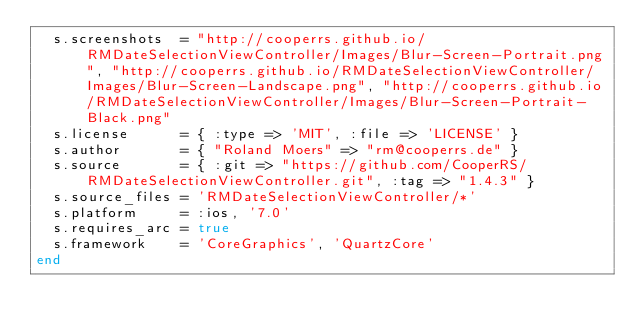<code> <loc_0><loc_0><loc_500><loc_500><_Ruby_>  s.screenshots  = "http://cooperrs.github.io/RMDateSelectionViewController/Images/Blur-Screen-Portrait.png", "http://cooperrs.github.io/RMDateSelectionViewController/Images/Blur-Screen-Landscape.png", "http://cooperrs.github.io/RMDateSelectionViewController/Images/Blur-Screen-Portrait-Black.png"
  s.license      = { :type => 'MIT', :file => 'LICENSE' }
  s.author       = { "Roland Moers" => "rm@cooperrs.de" }
  s.source       = { :git => "https://github.com/CooperRS/RMDateSelectionViewController.git", :tag => "1.4.3" }
  s.source_files = 'RMDateSelectionViewController/*'
  s.platform     = :ios, '7.0'
  s.requires_arc = true
  s.framework    = 'CoreGraphics', 'QuartzCore'
end
</code> 